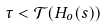<formula> <loc_0><loc_0><loc_500><loc_500>\tau < \mathcal { T } ( H _ { o } ( s ) ) \,</formula> 